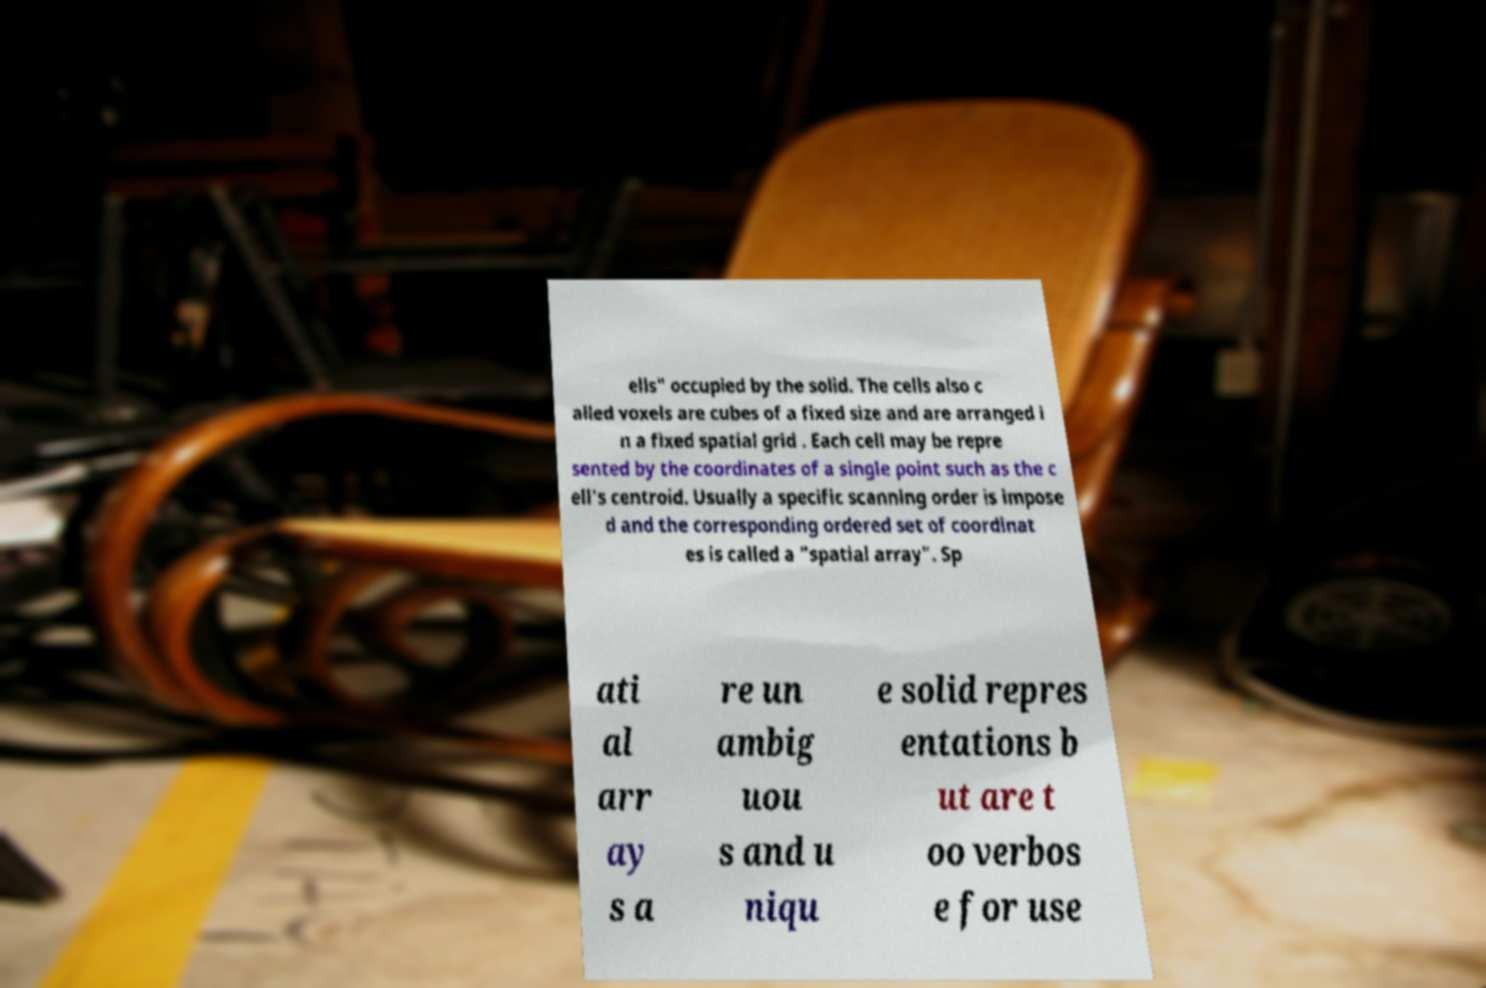What messages or text are displayed in this image? I need them in a readable, typed format. ells" occupied by the solid. The cells also c alled voxels are cubes of a fixed size and are arranged i n a fixed spatial grid . Each cell may be repre sented by the coordinates of a single point such as the c ell's centroid. Usually a specific scanning order is impose d and the corresponding ordered set of coordinat es is called a "spatial array". Sp ati al arr ay s a re un ambig uou s and u niqu e solid repres entations b ut are t oo verbos e for use 